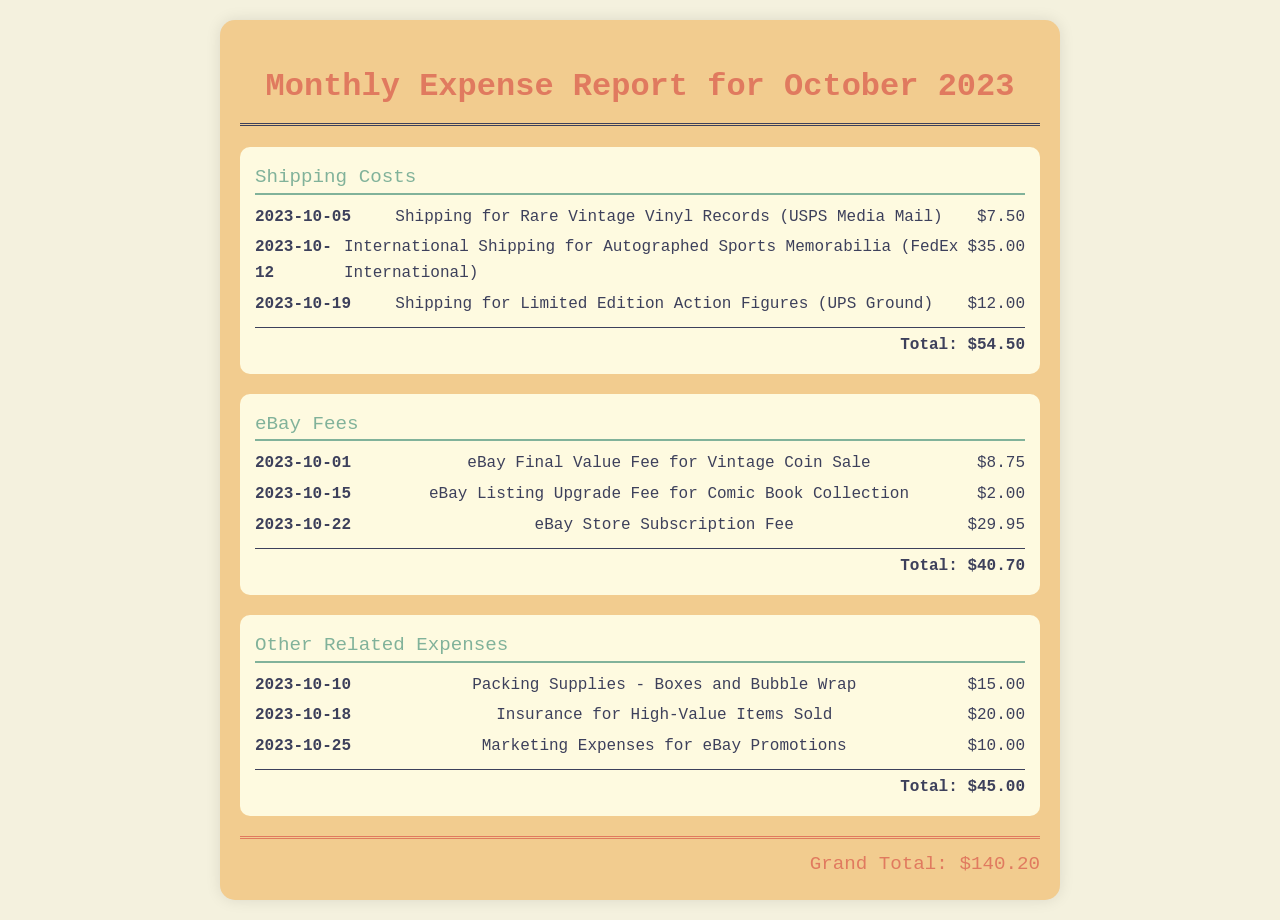What is the total shipping cost for October 2023? The total shipping cost is the sum of all shipping expenses listed in the document, which is $7.50 + $35.00 + $12.00 = $54.50.
Answer: $54.50 What date was the insurance for high-value items purchased? The document lists the date for insurance as October 18, 2023.
Answer: 2023-10-18 How much was spent on eBay fees? The total eBay fees is the sum of all listed eBay expenses, which is $8.75 + $2.00 + $29.95 = $40.70.
Answer: $40.70 What item incurred the highest shipping cost? The international shipping for autographed sports memorabilia is listed at the highest cost among shipping expenses.
Answer: International Shipping for Autographed Sports Memorabilia What is the grand total of all expenses for October 2023? The grand total is the sum of all expenses categorized - shipping costs, eBay fees, and other related expenses, which is $54.50 + $40.70 + $45.00 = $140.20.
Answer: $140.20 What expense was recorded on October 1, 2023? The eBay final value fee for the vintage coin sale was recorded on this date.
Answer: eBay Final Value Fee for Vintage Coin Sale How much was spent on packing supplies? The document lists the packing supplies expense as $15.00.
Answer: $15.00 Which shipping service was used for limited edition action figures? The shipping service used for the limited edition action figures was UPS Ground.
Answer: UPS Ground 